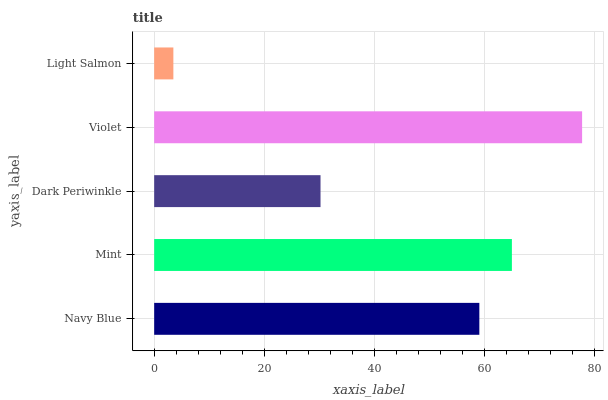Is Light Salmon the minimum?
Answer yes or no. Yes. Is Violet the maximum?
Answer yes or no. Yes. Is Mint the minimum?
Answer yes or no. No. Is Mint the maximum?
Answer yes or no. No. Is Mint greater than Navy Blue?
Answer yes or no. Yes. Is Navy Blue less than Mint?
Answer yes or no. Yes. Is Navy Blue greater than Mint?
Answer yes or no. No. Is Mint less than Navy Blue?
Answer yes or no. No. Is Navy Blue the high median?
Answer yes or no. Yes. Is Navy Blue the low median?
Answer yes or no. Yes. Is Dark Periwinkle the high median?
Answer yes or no. No. Is Light Salmon the low median?
Answer yes or no. No. 